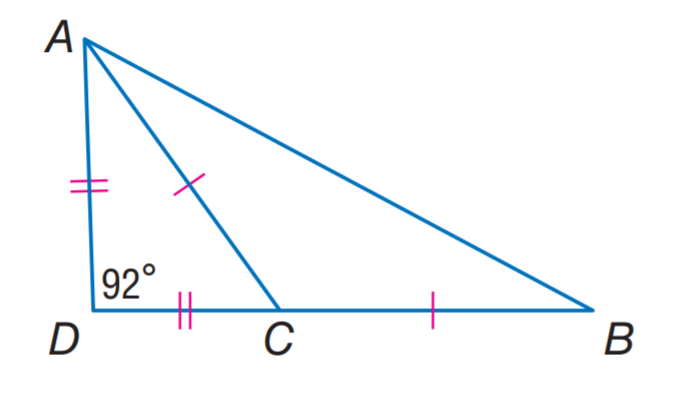Answer the mathemtical geometry problem and directly provide the correct option letter.
Question: Find m \angle A C D.
Choices: A: 22 B: 44 C: 66 D: 92 B 